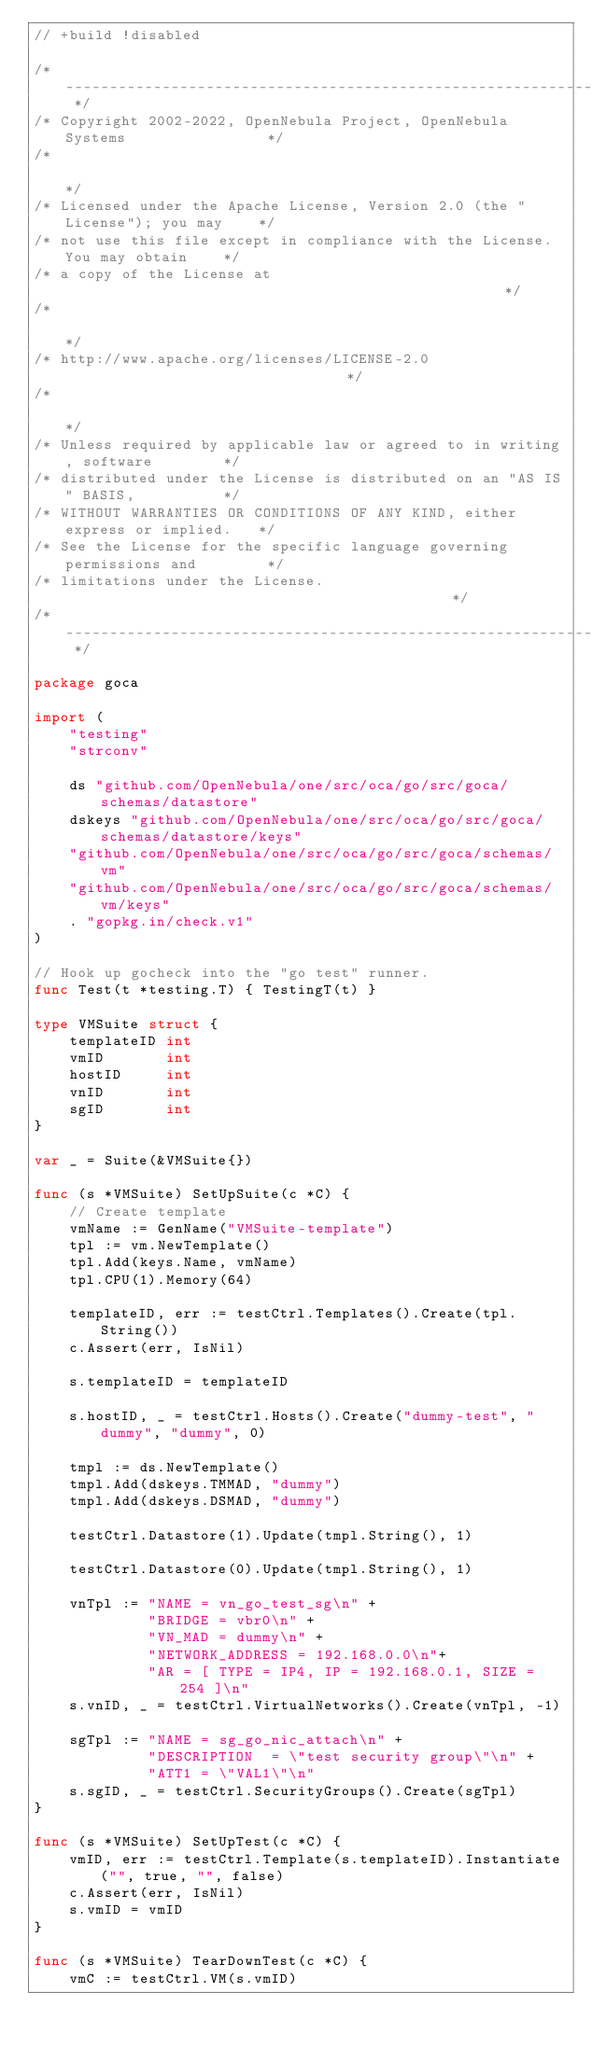Convert code to text. <code><loc_0><loc_0><loc_500><loc_500><_Go_>// +build !disabled

/* -------------------------------------------------------------------------- */
/* Copyright 2002-2022, OpenNebula Project, OpenNebula Systems                */
/*                                                                            */
/* Licensed under the Apache License, Version 2.0 (the "License"); you may    */
/* not use this file except in compliance with the License. You may obtain    */
/* a copy of the License at                                                   */
/*                                                                            */
/* http://www.apache.org/licenses/LICENSE-2.0                                 */
/*                                                                            */
/* Unless required by applicable law or agreed to in writing, software        */
/* distributed under the License is distributed on an "AS IS" BASIS,          */
/* WITHOUT WARRANTIES OR CONDITIONS OF ANY KIND, either express or implied.   */
/* See the License for the specific language governing permissions and        */
/* limitations under the License.                                             */
/*--------------------------------------------------------------------------- */

package goca

import (
	"testing"
	"strconv"

	ds "github.com/OpenNebula/one/src/oca/go/src/goca/schemas/datastore"
	dskeys "github.com/OpenNebula/one/src/oca/go/src/goca/schemas/datastore/keys"
	"github.com/OpenNebula/one/src/oca/go/src/goca/schemas/vm"
	"github.com/OpenNebula/one/src/oca/go/src/goca/schemas/vm/keys"
	. "gopkg.in/check.v1"
)

// Hook up gocheck into the "go test" runner.
func Test(t *testing.T) { TestingT(t) }

type VMSuite struct {
	templateID int
	vmID       int
	hostID     int
	vnID       int
	sgID       int
}

var _ = Suite(&VMSuite{})

func (s *VMSuite) SetUpSuite(c *C) {
	// Create template
	vmName := GenName("VMSuite-template")
	tpl := vm.NewTemplate()
	tpl.Add(keys.Name, vmName)
	tpl.CPU(1).Memory(64)

	templateID, err := testCtrl.Templates().Create(tpl.String())
	c.Assert(err, IsNil)

	s.templateID = templateID

	s.hostID, _ = testCtrl.Hosts().Create("dummy-test", "dummy", "dummy", 0)

	tmpl := ds.NewTemplate()
	tmpl.Add(dskeys.TMMAD, "dummy")
	tmpl.Add(dskeys.DSMAD, "dummy")

	testCtrl.Datastore(1).Update(tmpl.String(), 1)

	testCtrl.Datastore(0).Update(tmpl.String(), 1)

	vnTpl := "NAME = vn_go_test_sg\n" +
			 "BRIDGE = vbr0\n" +
			 "VN_MAD = dummy\n" +
			 "NETWORK_ADDRESS = 192.168.0.0\n"+
			 "AR = [ TYPE = IP4, IP = 192.168.0.1, SIZE = 254 ]\n"
	s.vnID, _ = testCtrl.VirtualNetworks().Create(vnTpl, -1)

	sgTpl := "NAME = sg_go_nic_attach\n" +
			 "DESCRIPTION  = \"test security group\"\n" +
			 "ATT1 = \"VAL1\"\n"
	s.sgID, _ = testCtrl.SecurityGroups().Create(sgTpl)
}

func (s *VMSuite) SetUpTest(c *C) {
	vmID, err := testCtrl.Template(s.templateID).Instantiate("", true, "", false)
	c.Assert(err, IsNil)
	s.vmID = vmID
}

func (s *VMSuite) TearDownTest(c *C) {
	vmC := testCtrl.VM(s.vmID)</code> 